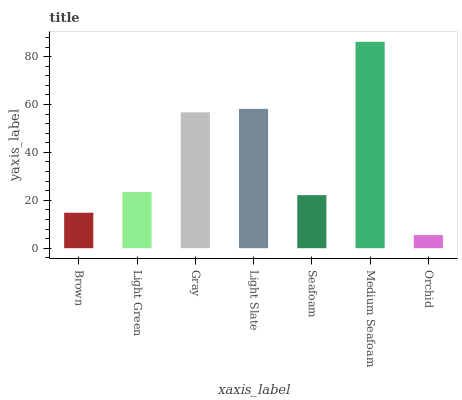Is Orchid the minimum?
Answer yes or no. Yes. Is Medium Seafoam the maximum?
Answer yes or no. Yes. Is Light Green the minimum?
Answer yes or no. No. Is Light Green the maximum?
Answer yes or no. No. Is Light Green greater than Brown?
Answer yes or no. Yes. Is Brown less than Light Green?
Answer yes or no. Yes. Is Brown greater than Light Green?
Answer yes or no. No. Is Light Green less than Brown?
Answer yes or no. No. Is Light Green the high median?
Answer yes or no. Yes. Is Light Green the low median?
Answer yes or no. Yes. Is Brown the high median?
Answer yes or no. No. Is Seafoam the low median?
Answer yes or no. No. 